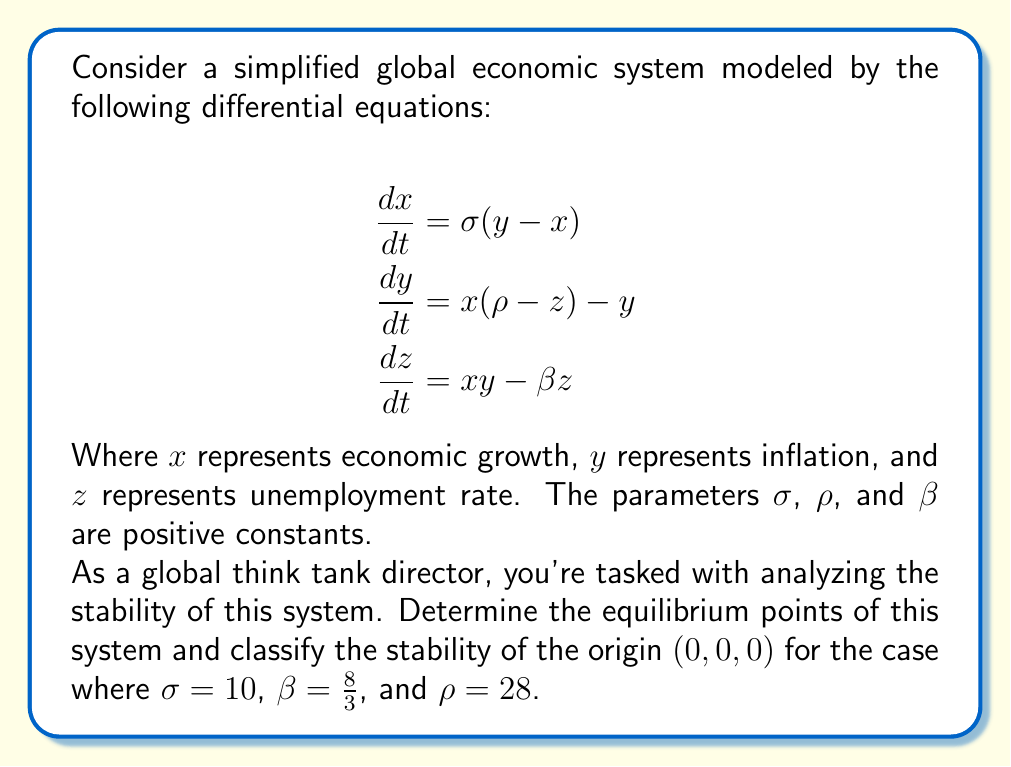Can you answer this question? To analyze the stability of this system, we'll follow these steps:

1) Find the equilibrium points:
Set all derivatives to zero and solve the resulting system of equations:

$$\begin{align}
0 &= \sigma(y - x) \\
0 &= x(\rho - z) - y \\
0 &= xy - \beta z
\end{align}$$

From the first equation: $y = x$
Substituting this into the second equation:
$0 = x(\rho - z) - x = x(\rho - z - 1)$

This gives us two possibilities:
a) $x = 0$, which leads to $y = 0$ and $z = 0$, giving the equilibrium point $(0,0,0)$
b) $\rho - z - 1 = 0$, or $z = \rho - 1$

For case b, substituting $y = x$ and $z = \rho - 1$ into the third equation:
$x^2 = \beta(\rho - 1)$

This gives us two more equilibrium points:
$(\pm\sqrt{\beta(\rho-1)}, \pm\sqrt{\beta(\rho-1)}, \rho-1)$

2) Analyze stability at the origin:
To determine the stability at $(0,0,0)$, we need to find the Jacobian matrix and evaluate it at this point:

$$J = \begin{bmatrix}
-\sigma & \sigma & 0 \\
\rho - z & -1 & -x \\
y & x & -\beta
\end{bmatrix}$$

At $(0,0,0)$:

$$J_{(0,0,0)} = \begin{bmatrix}
-\sigma & \sigma & 0 \\
\rho & -1 & 0 \\
0 & 0 & -\beta
\end{bmatrix}$$

3) Find the eigenvalues:
The characteristic equation is:
$$\det(J_{(0,0,0)} - \lambda I) = 0$$

$$\begin{vmatrix}
-\sigma - \lambda & \sigma & 0 \\
\rho & -1 - \lambda & 0 \\
0 & 0 & -\beta - \lambda
\end{vmatrix} = 0$$

$(-\beta - \lambda)[(-\sigma - \lambda)(-1 - \lambda) - \sigma\rho] = 0$

This gives us:
$\lambda_1 = -\beta$
and the other two roots from:
$\lambda^2 + (\sigma + 1)\lambda + \sigma(1-\rho) = 0$

4) Substitute the given values:
$\sigma = 10$, $\beta = \frac{8}{3}$, and $\rho = 28$

$\lambda_1 = -\frac{8}{3}$

For the quadratic:
$\lambda^2 + 11\lambda - 270 = 0$

Solving this:
$\lambda_{2,3} = \frac{-11 \pm \sqrt{121 + 1080}}{2} = \frac{-11 \pm \sqrt{1201}}{2}$

$\lambda_2 \approx 11.91$ (positive)
$\lambda_3 \approx -22.91$ (negative)

5) Interpret the results:
Since we have one positive eigenvalue ($\lambda_2$), the equilibrium point at the origin is unstable. Specifically, it's a saddle point, as we have eigenvalues with different signs.
Answer: The system has three equilibrium points: $(0,0,0)$ and $(\pm\sqrt{\beta(\rho-1)}, \pm\sqrt{\beta(\rho-1)}, \rho-1)$. For the given parameters, the origin $(0,0,0)$ is an unstable equilibrium point (specifically, a saddle point), as it has eigenvalues $\lambda_1 = -\frac{8}{3}$, $\lambda_2 \approx 11.91$, and $\lambda_3 \approx -22.91$. 